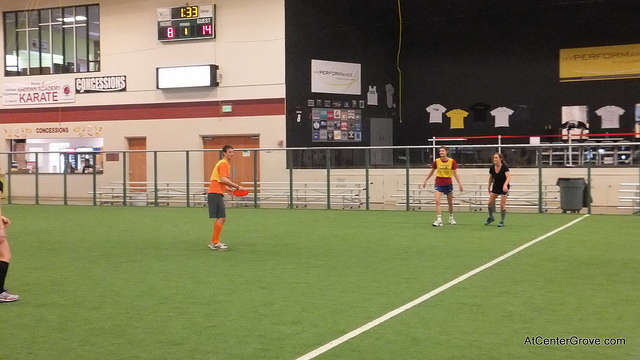Extract all visible text content from this image. KARATE CONCESSIONS CONCESSIONS AtCenterGrove.com PERFORM 8 1:33 14 